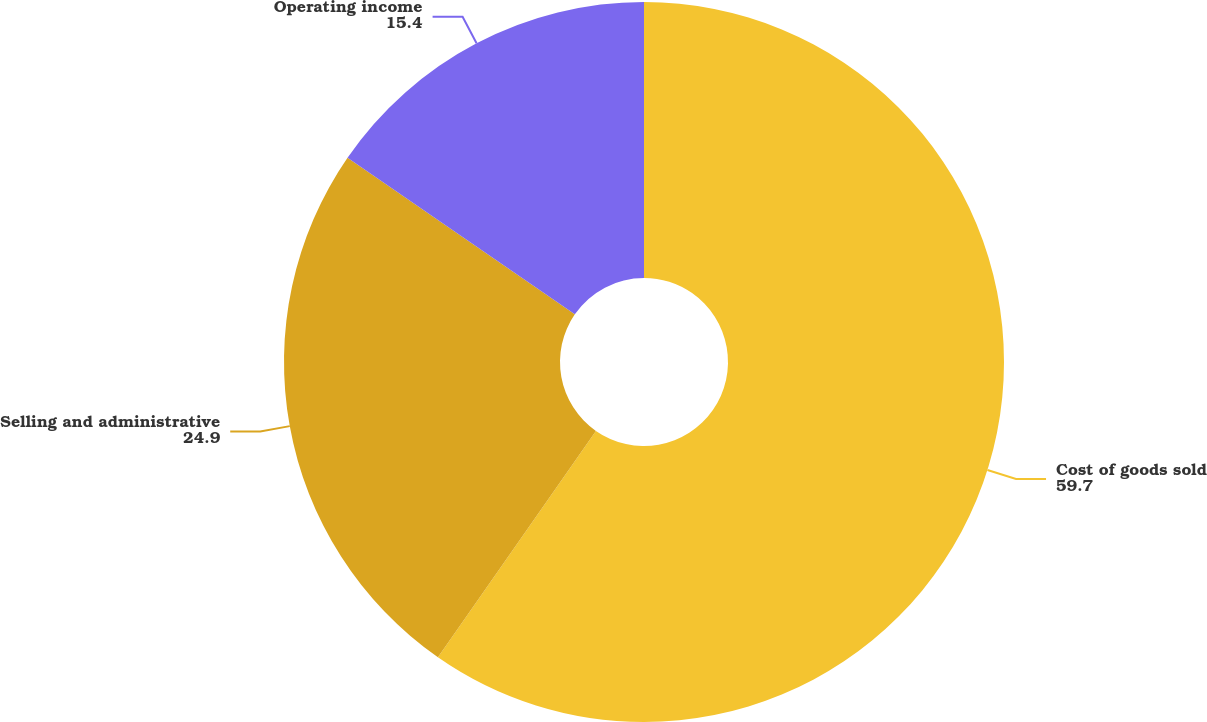Convert chart to OTSL. <chart><loc_0><loc_0><loc_500><loc_500><pie_chart><fcel>Cost of goods sold<fcel>Selling and administrative<fcel>Operating income<nl><fcel>59.7%<fcel>24.9%<fcel>15.4%<nl></chart> 